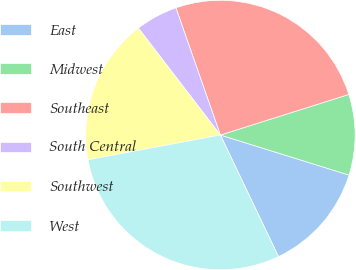<chart> <loc_0><loc_0><loc_500><loc_500><pie_chart><fcel>East<fcel>Midwest<fcel>Southeast<fcel>South Central<fcel>Southwest<fcel>West<nl><fcel>13.1%<fcel>9.68%<fcel>25.48%<fcel>5.06%<fcel>17.53%<fcel>29.15%<nl></chart> 